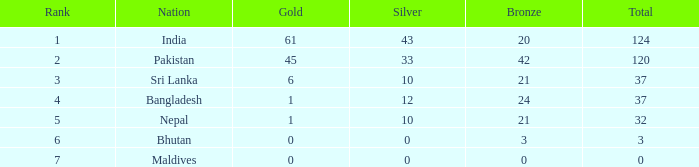Which Gold has a Rank smaller than 5, and a Bronze of 20? 61.0. 